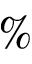<formula> <loc_0><loc_0><loc_500><loc_500>\%</formula> 